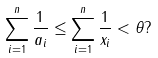<formula> <loc_0><loc_0><loc_500><loc_500>\sum _ { i = 1 } ^ { n } \frac { 1 } { a _ { i } } \leq \sum _ { i = 1 } ^ { n } \frac { 1 } { x _ { i } } < \theta ?</formula> 